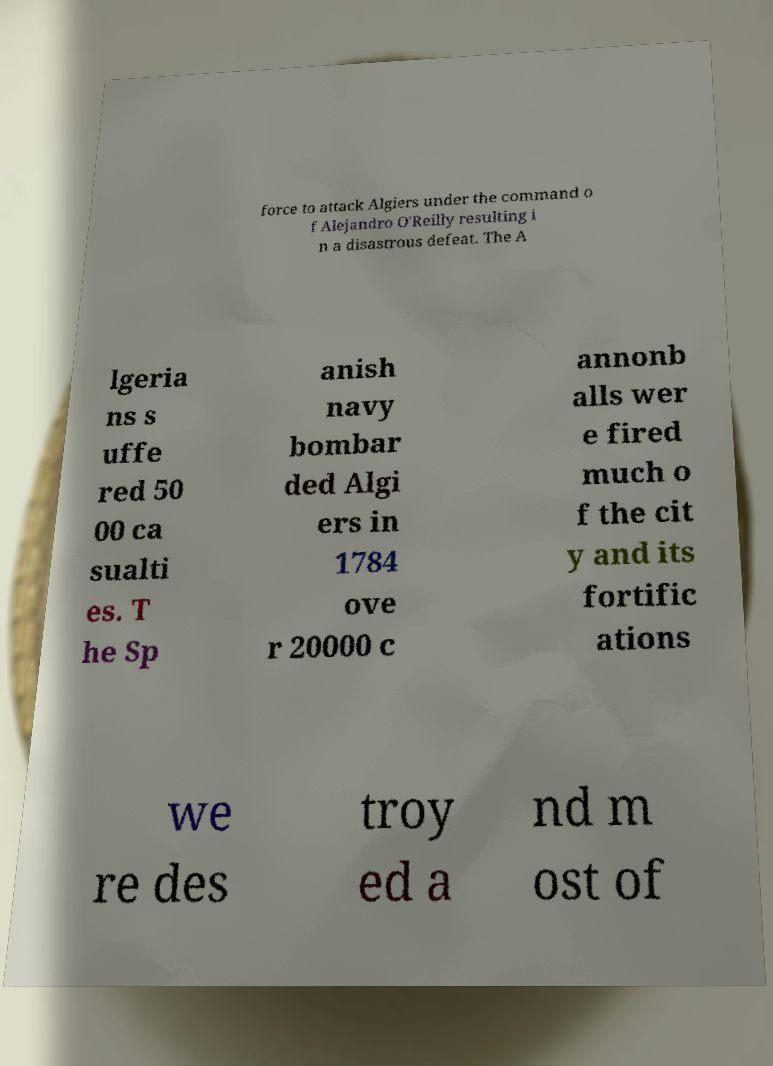Can you read and provide the text displayed in the image?This photo seems to have some interesting text. Can you extract and type it out for me? force to attack Algiers under the command o f Alejandro O'Reilly resulting i n a disastrous defeat. The A lgeria ns s uffe red 50 00 ca sualti es. T he Sp anish navy bombar ded Algi ers in 1784 ove r 20000 c annonb alls wer e fired much o f the cit y and its fortific ations we re des troy ed a nd m ost of 